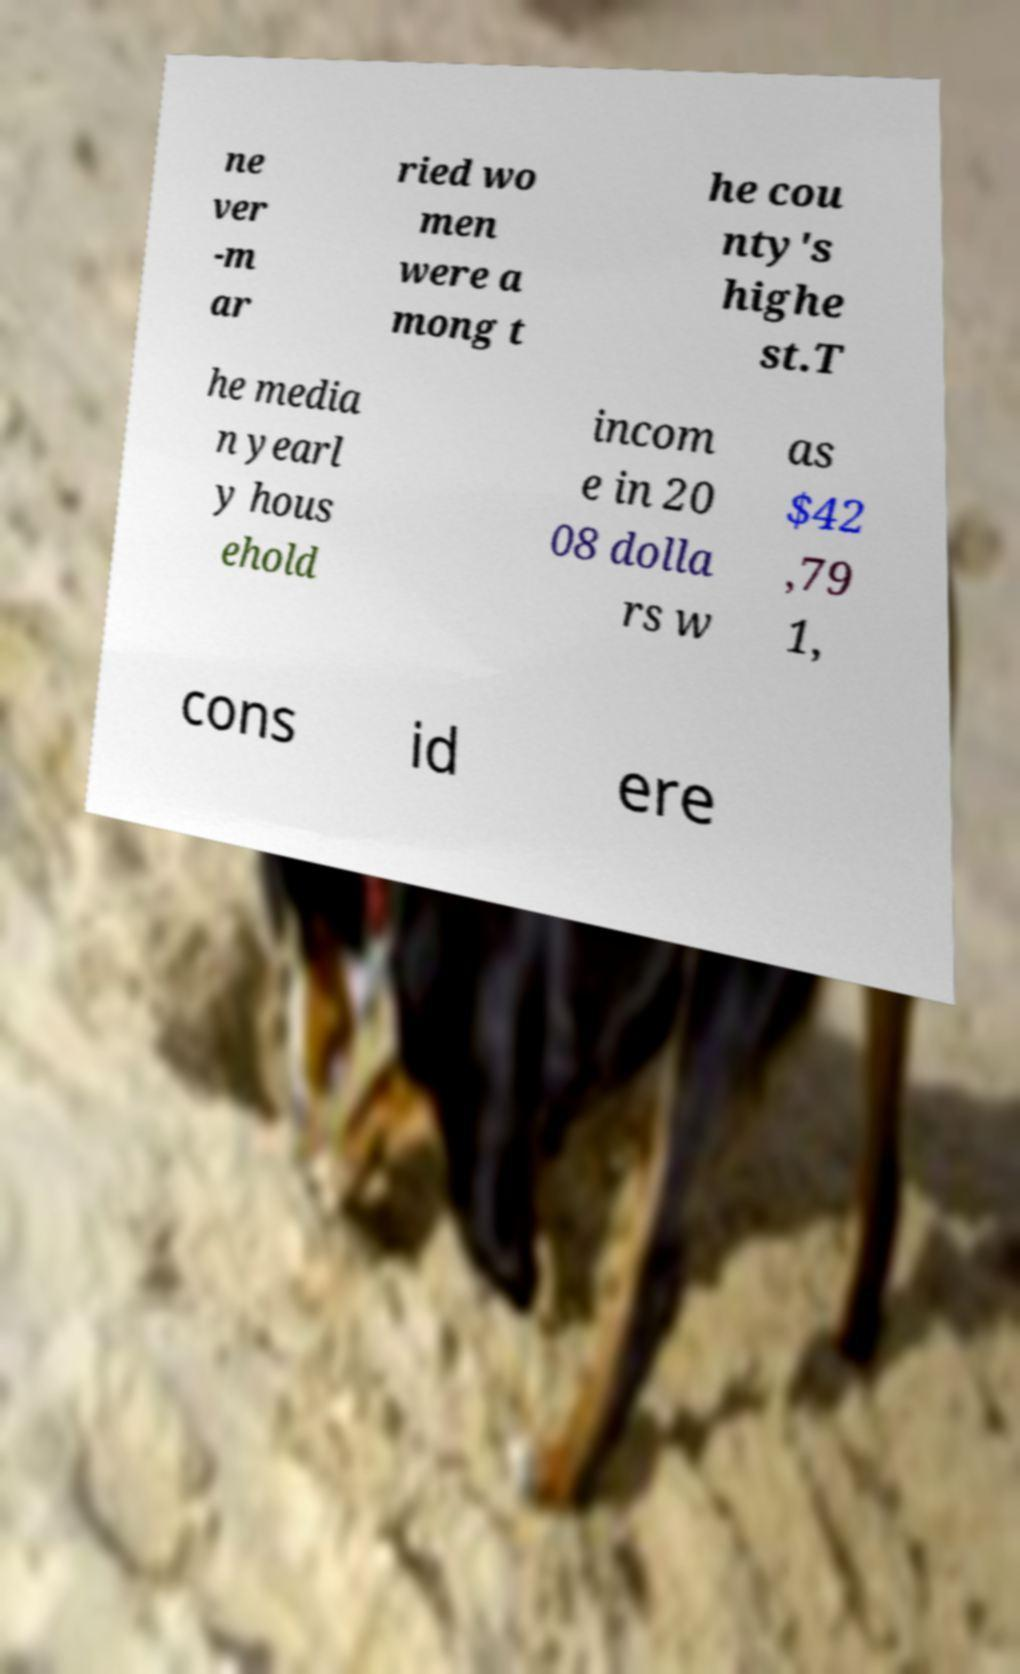For documentation purposes, I need the text within this image transcribed. Could you provide that? ne ver -m ar ried wo men were a mong t he cou nty's highe st.T he media n yearl y hous ehold incom e in 20 08 dolla rs w as $42 ,79 1, cons id ere 